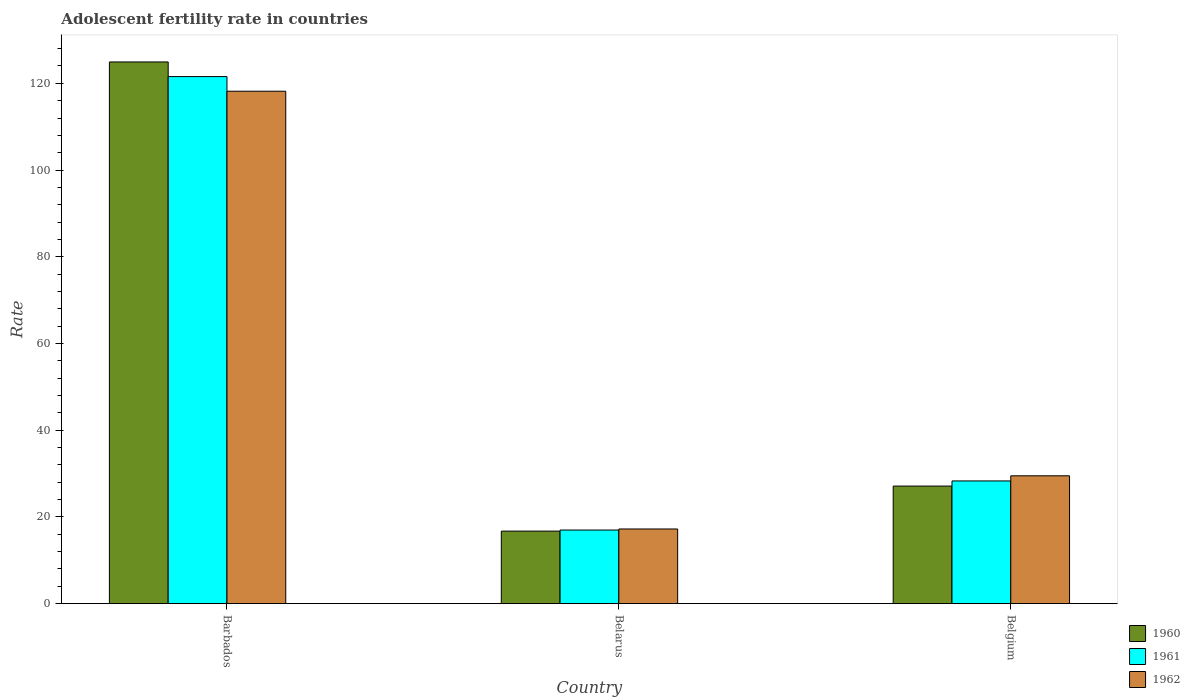How many groups of bars are there?
Make the answer very short. 3. Are the number of bars per tick equal to the number of legend labels?
Your response must be concise. Yes. Are the number of bars on each tick of the X-axis equal?
Keep it short and to the point. Yes. How many bars are there on the 2nd tick from the right?
Your answer should be very brief. 3. In how many cases, is the number of bars for a given country not equal to the number of legend labels?
Your response must be concise. 0. What is the adolescent fertility rate in 1961 in Belarus?
Provide a short and direct response. 16.97. Across all countries, what is the maximum adolescent fertility rate in 1962?
Keep it short and to the point. 118.18. Across all countries, what is the minimum adolescent fertility rate in 1962?
Make the answer very short. 17.22. In which country was the adolescent fertility rate in 1961 maximum?
Ensure brevity in your answer.  Barbados. In which country was the adolescent fertility rate in 1962 minimum?
Give a very brief answer. Belarus. What is the total adolescent fertility rate in 1962 in the graph?
Offer a terse response. 164.88. What is the difference between the adolescent fertility rate in 1961 in Barbados and that in Belgium?
Your answer should be very brief. 93.25. What is the difference between the adolescent fertility rate in 1961 in Belgium and the adolescent fertility rate in 1962 in Belarus?
Offer a terse response. 11.08. What is the average adolescent fertility rate in 1962 per country?
Ensure brevity in your answer.  54.96. What is the difference between the adolescent fertility rate of/in 1960 and adolescent fertility rate of/in 1961 in Belarus?
Give a very brief answer. -0.25. What is the ratio of the adolescent fertility rate in 1961 in Barbados to that in Belgium?
Your answer should be very brief. 4.3. Is the adolescent fertility rate in 1961 in Belarus less than that in Belgium?
Give a very brief answer. Yes. What is the difference between the highest and the second highest adolescent fertility rate in 1960?
Give a very brief answer. -10.39. What is the difference between the highest and the lowest adolescent fertility rate in 1962?
Provide a succinct answer. 100.96. Is the sum of the adolescent fertility rate in 1962 in Belarus and Belgium greater than the maximum adolescent fertility rate in 1961 across all countries?
Offer a terse response. No. What does the 2nd bar from the left in Belgium represents?
Give a very brief answer. 1961. What does the 2nd bar from the right in Belarus represents?
Make the answer very short. 1961. Is it the case that in every country, the sum of the adolescent fertility rate in 1960 and adolescent fertility rate in 1961 is greater than the adolescent fertility rate in 1962?
Give a very brief answer. Yes. How many bars are there?
Give a very brief answer. 9. Are all the bars in the graph horizontal?
Provide a short and direct response. No. What is the difference between two consecutive major ticks on the Y-axis?
Make the answer very short. 20. Does the graph contain any zero values?
Provide a short and direct response. No. Does the graph contain grids?
Your answer should be very brief. No. How are the legend labels stacked?
Your answer should be compact. Vertical. What is the title of the graph?
Offer a terse response. Adolescent fertility rate in countries. What is the label or title of the Y-axis?
Your response must be concise. Rate. What is the Rate in 1960 in Barbados?
Give a very brief answer. 124.93. What is the Rate of 1961 in Barbados?
Your answer should be compact. 121.55. What is the Rate in 1962 in Barbados?
Your response must be concise. 118.18. What is the Rate of 1960 in Belarus?
Ensure brevity in your answer.  16.73. What is the Rate of 1961 in Belarus?
Your answer should be compact. 16.97. What is the Rate of 1962 in Belarus?
Offer a very short reply. 17.22. What is the Rate of 1960 in Belgium?
Ensure brevity in your answer.  27.11. What is the Rate in 1961 in Belgium?
Your response must be concise. 28.3. What is the Rate in 1962 in Belgium?
Ensure brevity in your answer.  29.48. Across all countries, what is the maximum Rate of 1960?
Provide a short and direct response. 124.93. Across all countries, what is the maximum Rate of 1961?
Offer a very short reply. 121.55. Across all countries, what is the maximum Rate of 1962?
Your answer should be compact. 118.18. Across all countries, what is the minimum Rate of 1960?
Give a very brief answer. 16.73. Across all countries, what is the minimum Rate of 1961?
Provide a succinct answer. 16.97. Across all countries, what is the minimum Rate of 1962?
Offer a terse response. 17.22. What is the total Rate in 1960 in the graph?
Provide a succinct answer. 168.77. What is the total Rate of 1961 in the graph?
Your response must be concise. 166.82. What is the total Rate of 1962 in the graph?
Your answer should be very brief. 164.88. What is the difference between the Rate in 1960 in Barbados and that in Belarus?
Keep it short and to the point. 108.2. What is the difference between the Rate of 1961 in Barbados and that in Belarus?
Offer a terse response. 104.58. What is the difference between the Rate in 1962 in Barbados and that in Belarus?
Provide a short and direct response. 100.96. What is the difference between the Rate of 1960 in Barbados and that in Belgium?
Your answer should be very brief. 97.81. What is the difference between the Rate of 1961 in Barbados and that in Belgium?
Give a very brief answer. 93.25. What is the difference between the Rate of 1962 in Barbados and that in Belgium?
Offer a very short reply. 88.69. What is the difference between the Rate of 1960 in Belarus and that in Belgium?
Make the answer very short. -10.39. What is the difference between the Rate of 1961 in Belarus and that in Belgium?
Offer a very short reply. -11.32. What is the difference between the Rate of 1962 in Belarus and that in Belgium?
Make the answer very short. -12.26. What is the difference between the Rate in 1960 in Barbados and the Rate in 1961 in Belarus?
Offer a very short reply. 107.95. What is the difference between the Rate in 1960 in Barbados and the Rate in 1962 in Belarus?
Offer a terse response. 107.71. What is the difference between the Rate of 1961 in Barbados and the Rate of 1962 in Belarus?
Your answer should be compact. 104.33. What is the difference between the Rate of 1960 in Barbados and the Rate of 1961 in Belgium?
Ensure brevity in your answer.  96.63. What is the difference between the Rate in 1960 in Barbados and the Rate in 1962 in Belgium?
Offer a terse response. 95.44. What is the difference between the Rate in 1961 in Barbados and the Rate in 1962 in Belgium?
Provide a succinct answer. 92.07. What is the difference between the Rate in 1960 in Belarus and the Rate in 1961 in Belgium?
Your answer should be compact. -11.57. What is the difference between the Rate of 1960 in Belarus and the Rate of 1962 in Belgium?
Offer a very short reply. -12.76. What is the difference between the Rate of 1961 in Belarus and the Rate of 1962 in Belgium?
Ensure brevity in your answer.  -12.51. What is the average Rate in 1960 per country?
Offer a very short reply. 56.26. What is the average Rate of 1961 per country?
Keep it short and to the point. 55.61. What is the average Rate of 1962 per country?
Ensure brevity in your answer.  54.96. What is the difference between the Rate of 1960 and Rate of 1961 in Barbados?
Give a very brief answer. 3.38. What is the difference between the Rate of 1960 and Rate of 1962 in Barbados?
Provide a short and direct response. 6.75. What is the difference between the Rate of 1961 and Rate of 1962 in Barbados?
Your answer should be very brief. 3.38. What is the difference between the Rate in 1960 and Rate in 1961 in Belarus?
Offer a terse response. -0.25. What is the difference between the Rate of 1960 and Rate of 1962 in Belarus?
Offer a very short reply. -0.49. What is the difference between the Rate in 1961 and Rate in 1962 in Belarus?
Your answer should be compact. -0.25. What is the difference between the Rate in 1960 and Rate in 1961 in Belgium?
Make the answer very short. -1.18. What is the difference between the Rate in 1960 and Rate in 1962 in Belgium?
Offer a very short reply. -2.37. What is the difference between the Rate of 1961 and Rate of 1962 in Belgium?
Your response must be concise. -1.18. What is the ratio of the Rate of 1960 in Barbados to that in Belarus?
Your answer should be compact. 7.47. What is the ratio of the Rate in 1961 in Barbados to that in Belarus?
Your answer should be very brief. 7.16. What is the ratio of the Rate of 1962 in Barbados to that in Belarus?
Make the answer very short. 6.86. What is the ratio of the Rate in 1960 in Barbados to that in Belgium?
Ensure brevity in your answer.  4.61. What is the ratio of the Rate in 1961 in Barbados to that in Belgium?
Your response must be concise. 4.3. What is the ratio of the Rate in 1962 in Barbados to that in Belgium?
Your answer should be compact. 4.01. What is the ratio of the Rate in 1960 in Belarus to that in Belgium?
Your answer should be compact. 0.62. What is the ratio of the Rate in 1961 in Belarus to that in Belgium?
Provide a short and direct response. 0.6. What is the ratio of the Rate of 1962 in Belarus to that in Belgium?
Offer a very short reply. 0.58. What is the difference between the highest and the second highest Rate in 1960?
Give a very brief answer. 97.81. What is the difference between the highest and the second highest Rate in 1961?
Your response must be concise. 93.25. What is the difference between the highest and the second highest Rate of 1962?
Your answer should be very brief. 88.69. What is the difference between the highest and the lowest Rate of 1960?
Give a very brief answer. 108.2. What is the difference between the highest and the lowest Rate of 1961?
Offer a very short reply. 104.58. What is the difference between the highest and the lowest Rate in 1962?
Your answer should be very brief. 100.96. 